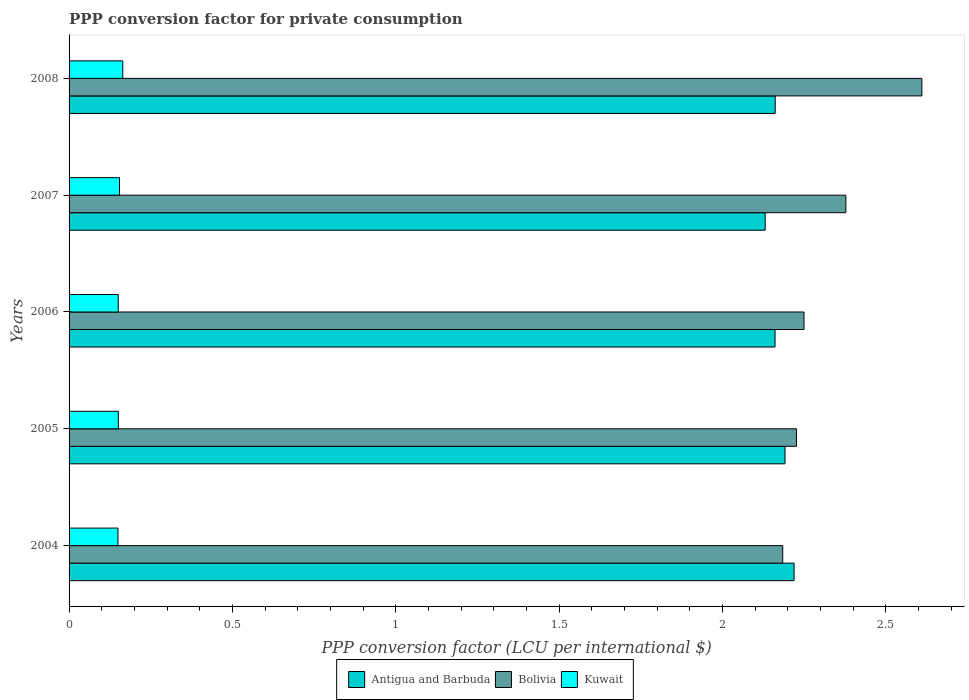How many groups of bars are there?
Give a very brief answer. 5. Are the number of bars per tick equal to the number of legend labels?
Ensure brevity in your answer.  Yes. What is the label of the 2nd group of bars from the top?
Offer a very short reply. 2007. What is the PPP conversion factor for private consumption in Antigua and Barbuda in 2006?
Give a very brief answer. 2.16. Across all years, what is the maximum PPP conversion factor for private consumption in Bolivia?
Ensure brevity in your answer.  2.61. Across all years, what is the minimum PPP conversion factor for private consumption in Kuwait?
Your answer should be compact. 0.15. In which year was the PPP conversion factor for private consumption in Bolivia maximum?
Your response must be concise. 2008. What is the total PPP conversion factor for private consumption in Kuwait in the graph?
Offer a very short reply. 0.77. What is the difference between the PPP conversion factor for private consumption in Bolivia in 2005 and that in 2008?
Ensure brevity in your answer.  -0.38. What is the difference between the PPP conversion factor for private consumption in Kuwait in 2004 and the PPP conversion factor for private consumption in Bolivia in 2007?
Ensure brevity in your answer.  -2.23. What is the average PPP conversion factor for private consumption in Bolivia per year?
Offer a very short reply. 2.33. In the year 2004, what is the difference between the PPP conversion factor for private consumption in Kuwait and PPP conversion factor for private consumption in Bolivia?
Your answer should be very brief. -2.03. What is the ratio of the PPP conversion factor for private consumption in Kuwait in 2005 to that in 2006?
Keep it short and to the point. 1. Is the PPP conversion factor for private consumption in Antigua and Barbuda in 2005 less than that in 2007?
Your response must be concise. No. What is the difference between the highest and the second highest PPP conversion factor for private consumption in Antigua and Barbuda?
Provide a succinct answer. 0.03. What is the difference between the highest and the lowest PPP conversion factor for private consumption in Bolivia?
Your answer should be very brief. 0.43. In how many years, is the PPP conversion factor for private consumption in Bolivia greater than the average PPP conversion factor for private consumption in Bolivia taken over all years?
Give a very brief answer. 2. Is the sum of the PPP conversion factor for private consumption in Kuwait in 2007 and 2008 greater than the maximum PPP conversion factor for private consumption in Bolivia across all years?
Keep it short and to the point. No. What does the 1st bar from the top in 2007 represents?
Ensure brevity in your answer.  Kuwait. What does the 2nd bar from the bottom in 2005 represents?
Provide a short and direct response. Bolivia. Is it the case that in every year, the sum of the PPP conversion factor for private consumption in Bolivia and PPP conversion factor for private consumption in Kuwait is greater than the PPP conversion factor for private consumption in Antigua and Barbuda?
Your answer should be compact. Yes. How many bars are there?
Keep it short and to the point. 15. What is the difference between two consecutive major ticks on the X-axis?
Offer a terse response. 0.5. Are the values on the major ticks of X-axis written in scientific E-notation?
Offer a terse response. No. Does the graph contain any zero values?
Give a very brief answer. No. Does the graph contain grids?
Your answer should be very brief. No. How many legend labels are there?
Your response must be concise. 3. What is the title of the graph?
Your answer should be compact. PPP conversion factor for private consumption. Does "Argentina" appear as one of the legend labels in the graph?
Offer a very short reply. No. What is the label or title of the X-axis?
Provide a short and direct response. PPP conversion factor (LCU per international $). What is the PPP conversion factor (LCU per international $) of Antigua and Barbuda in 2004?
Your answer should be very brief. 2.22. What is the PPP conversion factor (LCU per international $) of Bolivia in 2004?
Provide a succinct answer. 2.18. What is the PPP conversion factor (LCU per international $) in Kuwait in 2004?
Keep it short and to the point. 0.15. What is the PPP conversion factor (LCU per international $) of Antigua and Barbuda in 2005?
Provide a short and direct response. 2.19. What is the PPP conversion factor (LCU per international $) in Bolivia in 2005?
Give a very brief answer. 2.23. What is the PPP conversion factor (LCU per international $) in Kuwait in 2005?
Keep it short and to the point. 0.15. What is the PPP conversion factor (LCU per international $) in Antigua and Barbuda in 2006?
Provide a short and direct response. 2.16. What is the PPP conversion factor (LCU per international $) in Bolivia in 2006?
Your answer should be compact. 2.25. What is the PPP conversion factor (LCU per international $) in Kuwait in 2006?
Provide a succinct answer. 0.15. What is the PPP conversion factor (LCU per international $) in Antigua and Barbuda in 2007?
Provide a succinct answer. 2.13. What is the PPP conversion factor (LCU per international $) of Bolivia in 2007?
Give a very brief answer. 2.38. What is the PPP conversion factor (LCU per international $) of Kuwait in 2007?
Keep it short and to the point. 0.15. What is the PPP conversion factor (LCU per international $) in Antigua and Barbuda in 2008?
Offer a very short reply. 2.16. What is the PPP conversion factor (LCU per international $) of Bolivia in 2008?
Provide a short and direct response. 2.61. What is the PPP conversion factor (LCU per international $) in Kuwait in 2008?
Your answer should be very brief. 0.16. Across all years, what is the maximum PPP conversion factor (LCU per international $) of Antigua and Barbuda?
Make the answer very short. 2.22. Across all years, what is the maximum PPP conversion factor (LCU per international $) in Bolivia?
Offer a terse response. 2.61. Across all years, what is the maximum PPP conversion factor (LCU per international $) of Kuwait?
Keep it short and to the point. 0.16. Across all years, what is the minimum PPP conversion factor (LCU per international $) of Antigua and Barbuda?
Keep it short and to the point. 2.13. Across all years, what is the minimum PPP conversion factor (LCU per international $) in Bolivia?
Make the answer very short. 2.18. Across all years, what is the minimum PPP conversion factor (LCU per international $) of Kuwait?
Keep it short and to the point. 0.15. What is the total PPP conversion factor (LCU per international $) in Antigua and Barbuda in the graph?
Ensure brevity in your answer.  10.86. What is the total PPP conversion factor (LCU per international $) in Bolivia in the graph?
Provide a succinct answer. 11.65. What is the total PPP conversion factor (LCU per international $) in Kuwait in the graph?
Ensure brevity in your answer.  0.77. What is the difference between the PPP conversion factor (LCU per international $) in Antigua and Barbuda in 2004 and that in 2005?
Offer a terse response. 0.03. What is the difference between the PPP conversion factor (LCU per international $) of Bolivia in 2004 and that in 2005?
Your response must be concise. -0.04. What is the difference between the PPP conversion factor (LCU per international $) of Kuwait in 2004 and that in 2005?
Provide a short and direct response. -0. What is the difference between the PPP conversion factor (LCU per international $) in Antigua and Barbuda in 2004 and that in 2006?
Offer a very short reply. 0.06. What is the difference between the PPP conversion factor (LCU per international $) in Bolivia in 2004 and that in 2006?
Provide a short and direct response. -0.07. What is the difference between the PPP conversion factor (LCU per international $) of Kuwait in 2004 and that in 2006?
Give a very brief answer. -0. What is the difference between the PPP conversion factor (LCU per international $) of Antigua and Barbuda in 2004 and that in 2007?
Make the answer very short. 0.09. What is the difference between the PPP conversion factor (LCU per international $) of Bolivia in 2004 and that in 2007?
Your answer should be compact. -0.19. What is the difference between the PPP conversion factor (LCU per international $) in Kuwait in 2004 and that in 2007?
Your answer should be compact. -0. What is the difference between the PPP conversion factor (LCU per international $) in Antigua and Barbuda in 2004 and that in 2008?
Offer a terse response. 0.06. What is the difference between the PPP conversion factor (LCU per international $) of Bolivia in 2004 and that in 2008?
Keep it short and to the point. -0.43. What is the difference between the PPP conversion factor (LCU per international $) in Kuwait in 2004 and that in 2008?
Make the answer very short. -0.01. What is the difference between the PPP conversion factor (LCU per international $) of Antigua and Barbuda in 2005 and that in 2006?
Give a very brief answer. 0.03. What is the difference between the PPP conversion factor (LCU per international $) in Bolivia in 2005 and that in 2006?
Your answer should be compact. -0.02. What is the difference between the PPP conversion factor (LCU per international $) in Antigua and Barbuda in 2005 and that in 2007?
Your answer should be compact. 0.06. What is the difference between the PPP conversion factor (LCU per international $) in Bolivia in 2005 and that in 2007?
Ensure brevity in your answer.  -0.15. What is the difference between the PPP conversion factor (LCU per international $) of Kuwait in 2005 and that in 2007?
Your answer should be very brief. -0. What is the difference between the PPP conversion factor (LCU per international $) in Bolivia in 2005 and that in 2008?
Your response must be concise. -0.38. What is the difference between the PPP conversion factor (LCU per international $) of Kuwait in 2005 and that in 2008?
Your answer should be very brief. -0.01. What is the difference between the PPP conversion factor (LCU per international $) in Antigua and Barbuda in 2006 and that in 2007?
Offer a terse response. 0.03. What is the difference between the PPP conversion factor (LCU per international $) of Bolivia in 2006 and that in 2007?
Your answer should be compact. -0.13. What is the difference between the PPP conversion factor (LCU per international $) in Kuwait in 2006 and that in 2007?
Provide a short and direct response. -0. What is the difference between the PPP conversion factor (LCU per international $) in Antigua and Barbuda in 2006 and that in 2008?
Your answer should be very brief. -0. What is the difference between the PPP conversion factor (LCU per international $) of Bolivia in 2006 and that in 2008?
Offer a terse response. -0.36. What is the difference between the PPP conversion factor (LCU per international $) of Kuwait in 2006 and that in 2008?
Your answer should be compact. -0.01. What is the difference between the PPP conversion factor (LCU per international $) in Antigua and Barbuda in 2007 and that in 2008?
Give a very brief answer. -0.03. What is the difference between the PPP conversion factor (LCU per international $) in Bolivia in 2007 and that in 2008?
Offer a terse response. -0.23. What is the difference between the PPP conversion factor (LCU per international $) in Kuwait in 2007 and that in 2008?
Keep it short and to the point. -0.01. What is the difference between the PPP conversion factor (LCU per international $) of Antigua and Barbuda in 2004 and the PPP conversion factor (LCU per international $) of Bolivia in 2005?
Your response must be concise. -0.01. What is the difference between the PPP conversion factor (LCU per international $) of Antigua and Barbuda in 2004 and the PPP conversion factor (LCU per international $) of Kuwait in 2005?
Make the answer very short. 2.07. What is the difference between the PPP conversion factor (LCU per international $) in Bolivia in 2004 and the PPP conversion factor (LCU per international $) in Kuwait in 2005?
Your response must be concise. 2.03. What is the difference between the PPP conversion factor (LCU per international $) in Antigua and Barbuda in 2004 and the PPP conversion factor (LCU per international $) in Bolivia in 2006?
Provide a short and direct response. -0.03. What is the difference between the PPP conversion factor (LCU per international $) in Antigua and Barbuda in 2004 and the PPP conversion factor (LCU per international $) in Kuwait in 2006?
Offer a terse response. 2.07. What is the difference between the PPP conversion factor (LCU per international $) of Bolivia in 2004 and the PPP conversion factor (LCU per international $) of Kuwait in 2006?
Give a very brief answer. 2.03. What is the difference between the PPP conversion factor (LCU per international $) of Antigua and Barbuda in 2004 and the PPP conversion factor (LCU per international $) of Bolivia in 2007?
Your answer should be compact. -0.16. What is the difference between the PPP conversion factor (LCU per international $) in Antigua and Barbuda in 2004 and the PPP conversion factor (LCU per international $) in Kuwait in 2007?
Keep it short and to the point. 2.06. What is the difference between the PPP conversion factor (LCU per international $) of Bolivia in 2004 and the PPP conversion factor (LCU per international $) of Kuwait in 2007?
Offer a very short reply. 2.03. What is the difference between the PPP conversion factor (LCU per international $) in Antigua and Barbuda in 2004 and the PPP conversion factor (LCU per international $) in Bolivia in 2008?
Make the answer very short. -0.39. What is the difference between the PPP conversion factor (LCU per international $) in Antigua and Barbuda in 2004 and the PPP conversion factor (LCU per international $) in Kuwait in 2008?
Give a very brief answer. 2.05. What is the difference between the PPP conversion factor (LCU per international $) of Bolivia in 2004 and the PPP conversion factor (LCU per international $) of Kuwait in 2008?
Keep it short and to the point. 2.02. What is the difference between the PPP conversion factor (LCU per international $) of Antigua and Barbuda in 2005 and the PPP conversion factor (LCU per international $) of Bolivia in 2006?
Provide a short and direct response. -0.06. What is the difference between the PPP conversion factor (LCU per international $) in Antigua and Barbuda in 2005 and the PPP conversion factor (LCU per international $) in Kuwait in 2006?
Offer a very short reply. 2.04. What is the difference between the PPP conversion factor (LCU per international $) in Bolivia in 2005 and the PPP conversion factor (LCU per international $) in Kuwait in 2006?
Give a very brief answer. 2.08. What is the difference between the PPP conversion factor (LCU per international $) of Antigua and Barbuda in 2005 and the PPP conversion factor (LCU per international $) of Bolivia in 2007?
Provide a succinct answer. -0.19. What is the difference between the PPP conversion factor (LCU per international $) of Antigua and Barbuda in 2005 and the PPP conversion factor (LCU per international $) of Kuwait in 2007?
Provide a succinct answer. 2.04. What is the difference between the PPP conversion factor (LCU per international $) in Bolivia in 2005 and the PPP conversion factor (LCU per international $) in Kuwait in 2007?
Offer a very short reply. 2.07. What is the difference between the PPP conversion factor (LCU per international $) of Antigua and Barbuda in 2005 and the PPP conversion factor (LCU per international $) of Bolivia in 2008?
Ensure brevity in your answer.  -0.42. What is the difference between the PPP conversion factor (LCU per international $) of Antigua and Barbuda in 2005 and the PPP conversion factor (LCU per international $) of Kuwait in 2008?
Keep it short and to the point. 2.03. What is the difference between the PPP conversion factor (LCU per international $) of Bolivia in 2005 and the PPP conversion factor (LCU per international $) of Kuwait in 2008?
Your response must be concise. 2.06. What is the difference between the PPP conversion factor (LCU per international $) in Antigua and Barbuda in 2006 and the PPP conversion factor (LCU per international $) in Bolivia in 2007?
Offer a very short reply. -0.22. What is the difference between the PPP conversion factor (LCU per international $) in Antigua and Barbuda in 2006 and the PPP conversion factor (LCU per international $) in Kuwait in 2007?
Make the answer very short. 2.01. What is the difference between the PPP conversion factor (LCU per international $) in Bolivia in 2006 and the PPP conversion factor (LCU per international $) in Kuwait in 2007?
Offer a terse response. 2.1. What is the difference between the PPP conversion factor (LCU per international $) of Antigua and Barbuda in 2006 and the PPP conversion factor (LCU per international $) of Bolivia in 2008?
Offer a terse response. -0.45. What is the difference between the PPP conversion factor (LCU per international $) of Antigua and Barbuda in 2006 and the PPP conversion factor (LCU per international $) of Kuwait in 2008?
Offer a terse response. 2. What is the difference between the PPP conversion factor (LCU per international $) in Bolivia in 2006 and the PPP conversion factor (LCU per international $) in Kuwait in 2008?
Your answer should be compact. 2.08. What is the difference between the PPP conversion factor (LCU per international $) in Antigua and Barbuda in 2007 and the PPP conversion factor (LCU per international $) in Bolivia in 2008?
Make the answer very short. -0.48. What is the difference between the PPP conversion factor (LCU per international $) of Antigua and Barbuda in 2007 and the PPP conversion factor (LCU per international $) of Kuwait in 2008?
Provide a succinct answer. 1.97. What is the difference between the PPP conversion factor (LCU per international $) in Bolivia in 2007 and the PPP conversion factor (LCU per international $) in Kuwait in 2008?
Make the answer very short. 2.21. What is the average PPP conversion factor (LCU per international $) of Antigua and Barbuda per year?
Make the answer very short. 2.17. What is the average PPP conversion factor (LCU per international $) of Bolivia per year?
Provide a short and direct response. 2.33. What is the average PPP conversion factor (LCU per international $) in Kuwait per year?
Give a very brief answer. 0.15. In the year 2004, what is the difference between the PPP conversion factor (LCU per international $) of Antigua and Barbuda and PPP conversion factor (LCU per international $) of Bolivia?
Make the answer very short. 0.03. In the year 2004, what is the difference between the PPP conversion factor (LCU per international $) in Antigua and Barbuda and PPP conversion factor (LCU per international $) in Kuwait?
Make the answer very short. 2.07. In the year 2004, what is the difference between the PPP conversion factor (LCU per international $) of Bolivia and PPP conversion factor (LCU per international $) of Kuwait?
Offer a terse response. 2.03. In the year 2005, what is the difference between the PPP conversion factor (LCU per international $) in Antigua and Barbuda and PPP conversion factor (LCU per international $) in Bolivia?
Provide a short and direct response. -0.04. In the year 2005, what is the difference between the PPP conversion factor (LCU per international $) of Antigua and Barbuda and PPP conversion factor (LCU per international $) of Kuwait?
Make the answer very short. 2.04. In the year 2005, what is the difference between the PPP conversion factor (LCU per international $) of Bolivia and PPP conversion factor (LCU per international $) of Kuwait?
Keep it short and to the point. 2.08. In the year 2006, what is the difference between the PPP conversion factor (LCU per international $) of Antigua and Barbuda and PPP conversion factor (LCU per international $) of Bolivia?
Give a very brief answer. -0.09. In the year 2006, what is the difference between the PPP conversion factor (LCU per international $) in Antigua and Barbuda and PPP conversion factor (LCU per international $) in Kuwait?
Provide a short and direct response. 2.01. In the year 2006, what is the difference between the PPP conversion factor (LCU per international $) in Bolivia and PPP conversion factor (LCU per international $) in Kuwait?
Provide a short and direct response. 2.1. In the year 2007, what is the difference between the PPP conversion factor (LCU per international $) in Antigua and Barbuda and PPP conversion factor (LCU per international $) in Bolivia?
Make the answer very short. -0.25. In the year 2007, what is the difference between the PPP conversion factor (LCU per international $) of Antigua and Barbuda and PPP conversion factor (LCU per international $) of Kuwait?
Provide a succinct answer. 1.98. In the year 2007, what is the difference between the PPP conversion factor (LCU per international $) of Bolivia and PPP conversion factor (LCU per international $) of Kuwait?
Your answer should be very brief. 2.22. In the year 2008, what is the difference between the PPP conversion factor (LCU per international $) of Antigua and Barbuda and PPP conversion factor (LCU per international $) of Bolivia?
Provide a succinct answer. -0.45. In the year 2008, what is the difference between the PPP conversion factor (LCU per international $) in Antigua and Barbuda and PPP conversion factor (LCU per international $) in Kuwait?
Your answer should be very brief. 2. In the year 2008, what is the difference between the PPP conversion factor (LCU per international $) in Bolivia and PPP conversion factor (LCU per international $) in Kuwait?
Your response must be concise. 2.45. What is the ratio of the PPP conversion factor (LCU per international $) in Antigua and Barbuda in 2004 to that in 2005?
Keep it short and to the point. 1.01. What is the ratio of the PPP conversion factor (LCU per international $) in Bolivia in 2004 to that in 2006?
Your response must be concise. 0.97. What is the ratio of the PPP conversion factor (LCU per international $) of Antigua and Barbuda in 2004 to that in 2007?
Your response must be concise. 1.04. What is the ratio of the PPP conversion factor (LCU per international $) in Bolivia in 2004 to that in 2007?
Ensure brevity in your answer.  0.92. What is the ratio of the PPP conversion factor (LCU per international $) in Kuwait in 2004 to that in 2007?
Your answer should be compact. 0.97. What is the ratio of the PPP conversion factor (LCU per international $) in Antigua and Barbuda in 2004 to that in 2008?
Your response must be concise. 1.03. What is the ratio of the PPP conversion factor (LCU per international $) in Bolivia in 2004 to that in 2008?
Offer a terse response. 0.84. What is the ratio of the PPP conversion factor (LCU per international $) in Kuwait in 2004 to that in 2008?
Provide a short and direct response. 0.91. What is the ratio of the PPP conversion factor (LCU per international $) of Antigua and Barbuda in 2005 to that in 2006?
Offer a very short reply. 1.01. What is the ratio of the PPP conversion factor (LCU per international $) of Bolivia in 2005 to that in 2006?
Your answer should be compact. 0.99. What is the ratio of the PPP conversion factor (LCU per international $) in Antigua and Barbuda in 2005 to that in 2007?
Offer a terse response. 1.03. What is the ratio of the PPP conversion factor (LCU per international $) in Bolivia in 2005 to that in 2007?
Provide a short and direct response. 0.94. What is the ratio of the PPP conversion factor (LCU per international $) of Kuwait in 2005 to that in 2007?
Offer a very short reply. 0.98. What is the ratio of the PPP conversion factor (LCU per international $) in Antigua and Barbuda in 2005 to that in 2008?
Offer a terse response. 1.01. What is the ratio of the PPP conversion factor (LCU per international $) of Bolivia in 2005 to that in 2008?
Offer a very short reply. 0.85. What is the ratio of the PPP conversion factor (LCU per international $) in Kuwait in 2005 to that in 2008?
Your response must be concise. 0.92. What is the ratio of the PPP conversion factor (LCU per international $) in Antigua and Barbuda in 2006 to that in 2007?
Your response must be concise. 1.01. What is the ratio of the PPP conversion factor (LCU per international $) in Bolivia in 2006 to that in 2007?
Your response must be concise. 0.95. What is the ratio of the PPP conversion factor (LCU per international $) in Kuwait in 2006 to that in 2007?
Your response must be concise. 0.97. What is the ratio of the PPP conversion factor (LCU per international $) of Bolivia in 2006 to that in 2008?
Provide a succinct answer. 0.86. What is the ratio of the PPP conversion factor (LCU per international $) in Kuwait in 2006 to that in 2008?
Your answer should be very brief. 0.92. What is the ratio of the PPP conversion factor (LCU per international $) of Antigua and Barbuda in 2007 to that in 2008?
Provide a short and direct response. 0.99. What is the ratio of the PPP conversion factor (LCU per international $) of Bolivia in 2007 to that in 2008?
Provide a short and direct response. 0.91. What is the ratio of the PPP conversion factor (LCU per international $) in Kuwait in 2007 to that in 2008?
Make the answer very short. 0.94. What is the difference between the highest and the second highest PPP conversion factor (LCU per international $) of Antigua and Barbuda?
Provide a short and direct response. 0.03. What is the difference between the highest and the second highest PPP conversion factor (LCU per international $) in Bolivia?
Offer a very short reply. 0.23. What is the difference between the highest and the second highest PPP conversion factor (LCU per international $) in Kuwait?
Keep it short and to the point. 0.01. What is the difference between the highest and the lowest PPP conversion factor (LCU per international $) in Antigua and Barbuda?
Your answer should be very brief. 0.09. What is the difference between the highest and the lowest PPP conversion factor (LCU per international $) of Bolivia?
Your response must be concise. 0.43. What is the difference between the highest and the lowest PPP conversion factor (LCU per international $) of Kuwait?
Your response must be concise. 0.01. 